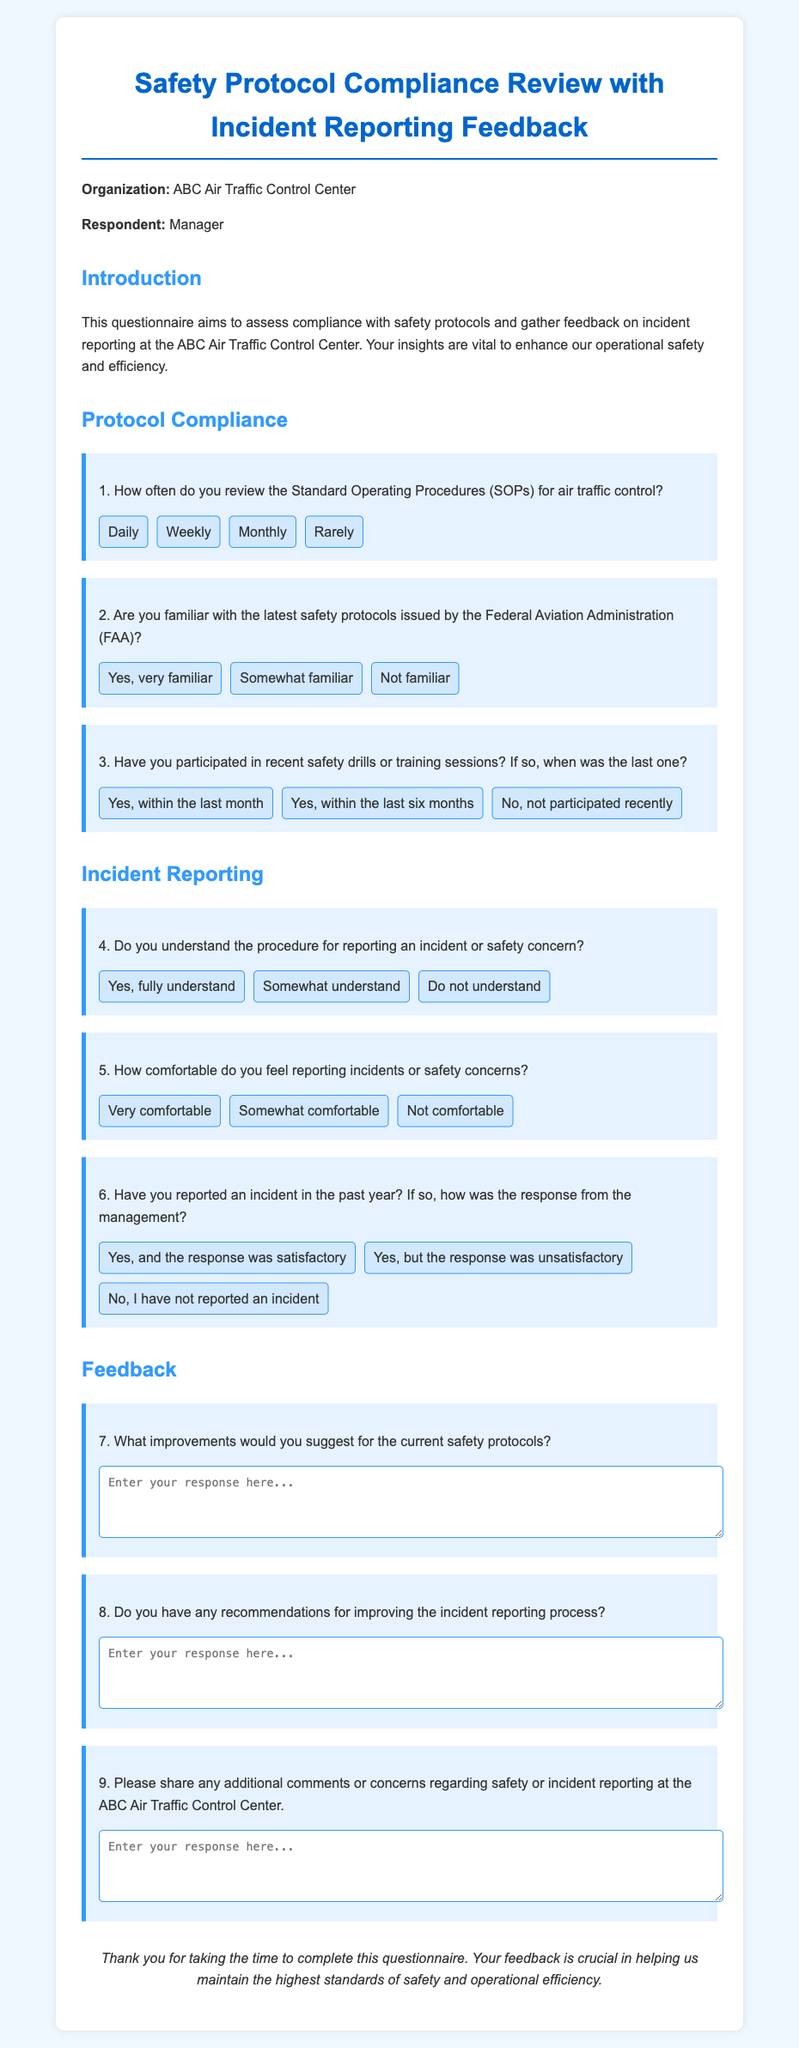What is the title of the document? The title is stated in the <title> tag of the document.
Answer: Safety Protocol Compliance Review Who is the organization mentioned in the document? The organization is explicitly mentioned in the introductory paragraph of the document.
Answer: ABC Air Traffic Control Center How often are the Standard Operating Procedures reviewed? The options for how often Standard Operating Procedures are reviewed are provided in the first question of the Protocol Compliance section.
Answer: Daily, Weekly, Monthly, Rarely What feedback is being sought for the incident reporting process? The document asks for recommendations to improve the incident reporting process specifically in question 8.
Answer: Suggestions How many questions are related to Incident Reporting? The document clearly separates the sections, with a specific header for Incident Reporting that includes defined questions.
Answer: Three questions Which safety protocols does the document refer to for compliance? The document refers to the latest safety protocols issued by the Federal Aviation Administration in question 2.
Answer: FAA When was the last safety drill mentioned? The timing of the last participation in safety drills or training sessions is covered in question 3 of the Protocol Compliance section.
Answer: Within the last month, within the last six months, not participated recently What type of feedback is requested in question 7? Question 7 specifically asks for improvements to the current safety protocols, indicating the focus of feedback.
Answer: Improvements Which section follows Protocol Compliance? The structure of the document indicates the sequence of sections clearly by headings.
Answer: Incident Reporting 